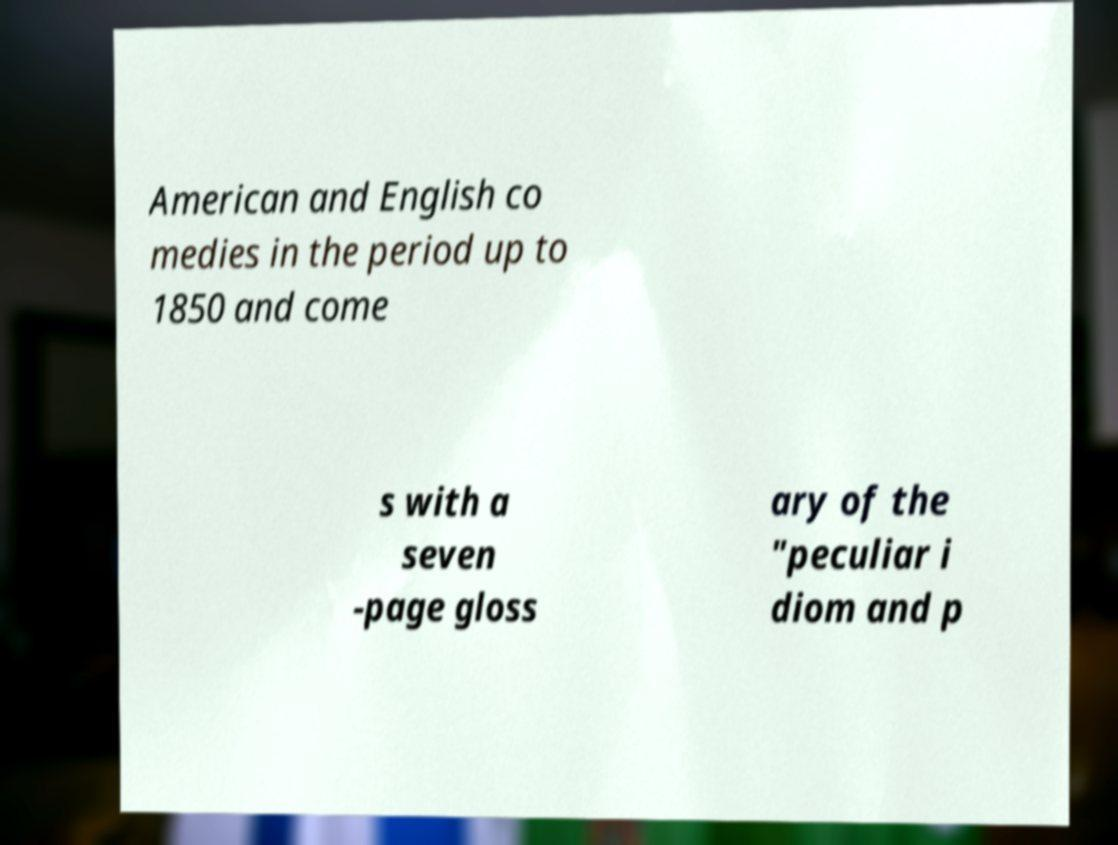Could you extract and type out the text from this image? American and English co medies in the period up to 1850 and come s with a seven -page gloss ary of the "peculiar i diom and p 